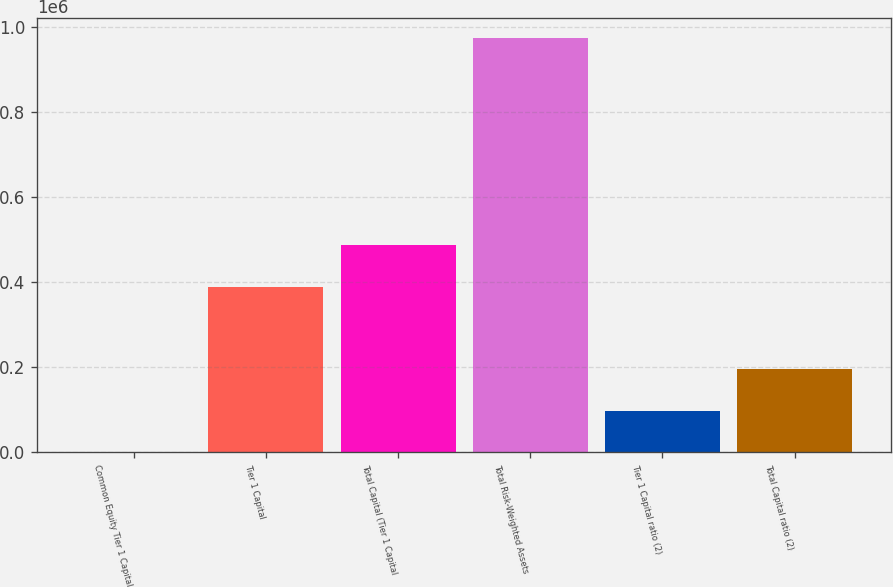<chart> <loc_0><loc_0><loc_500><loc_500><bar_chart><fcel>Common Equity Tier 1 Capital<fcel>Tier 1 Capital<fcel>Total Capital (Tier 1 Capital<fcel>Total Risk-Weighted Assets<fcel>Tier 1 Capital ratio (2)<fcel>Total Capital ratio (2)<nl><fcel>12.97<fcel>389503<fcel>486876<fcel>973739<fcel>97385.6<fcel>194758<nl></chart> 